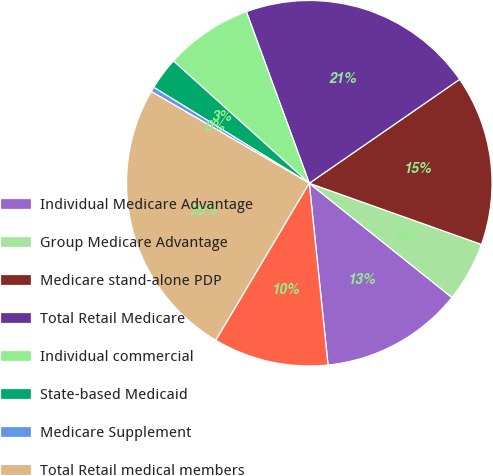Convert chart. <chart><loc_0><loc_0><loc_500><loc_500><pie_chart><fcel>Individual Medicare Advantage<fcel>Group Medicare Advantage<fcel>Medicare stand-alone PDP<fcel>Total Retail Medicare<fcel>Individual commercial<fcel>State-based Medicaid<fcel>Medicare Supplement<fcel>Total Retail medical members<fcel>Individual specialty<nl><fcel>12.62%<fcel>5.31%<fcel>15.06%<fcel>20.97%<fcel>7.74%<fcel>2.87%<fcel>0.43%<fcel>24.82%<fcel>10.18%<nl></chart> 